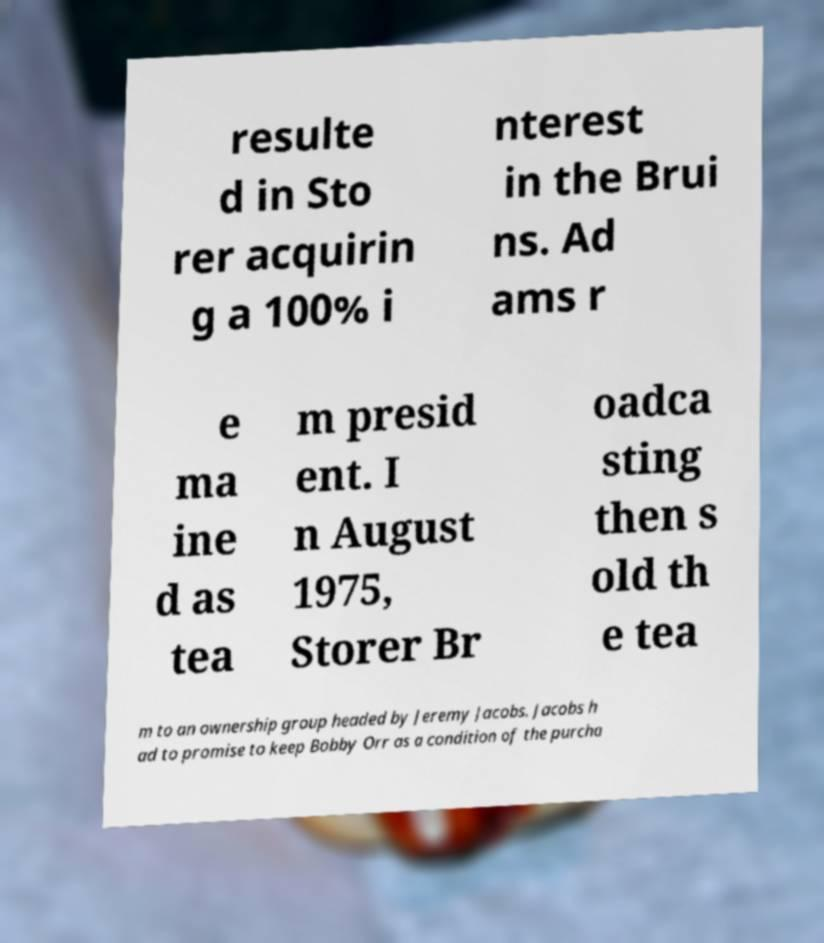I need the written content from this picture converted into text. Can you do that? resulte d in Sto rer acquirin g a 100% i nterest in the Brui ns. Ad ams r e ma ine d as tea m presid ent. I n August 1975, Storer Br oadca sting then s old th e tea m to an ownership group headed by Jeremy Jacobs. Jacobs h ad to promise to keep Bobby Orr as a condition of the purcha 